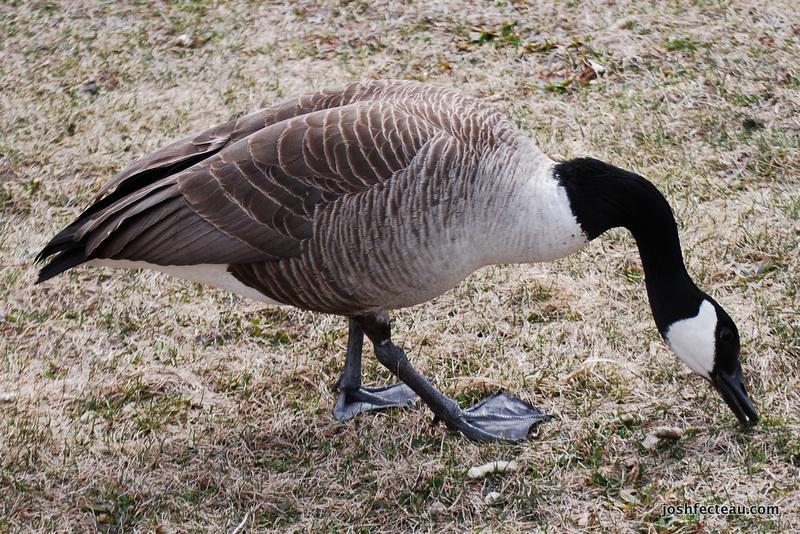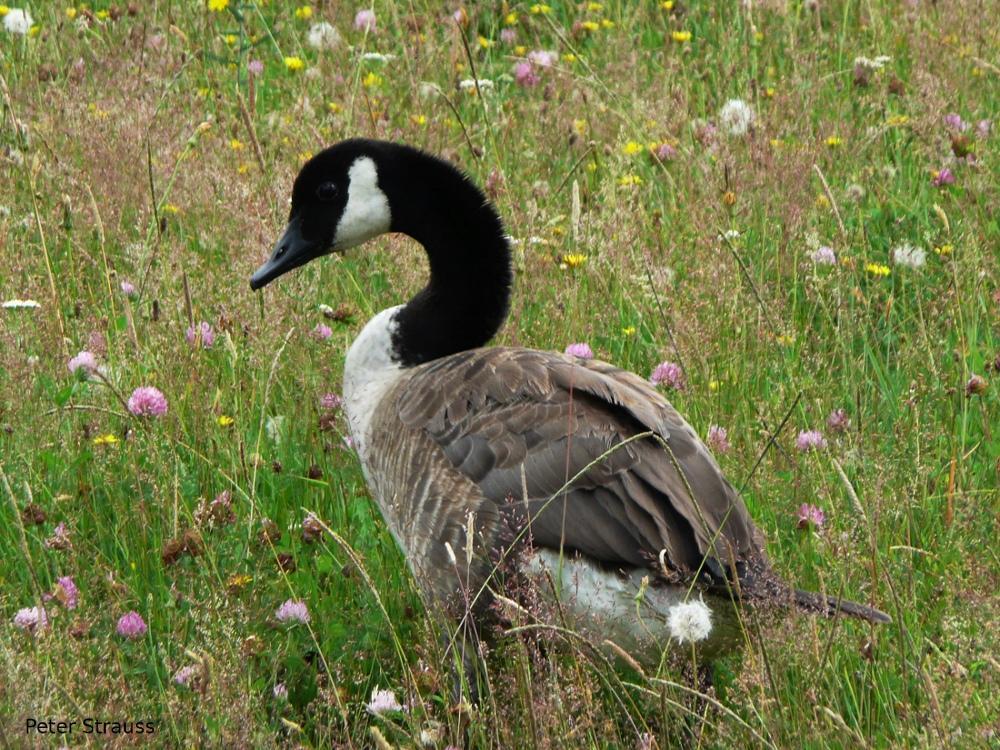The first image is the image on the left, the second image is the image on the right. Examine the images to the left and right. Is the description "No image contains more than two geese, and all geese are standing in grassy areas." accurate? Answer yes or no. Yes. The first image is the image on the left, the second image is the image on the right. Assess this claim about the two images: "The right image contains no more than one goose.". Correct or not? Answer yes or no. Yes. 